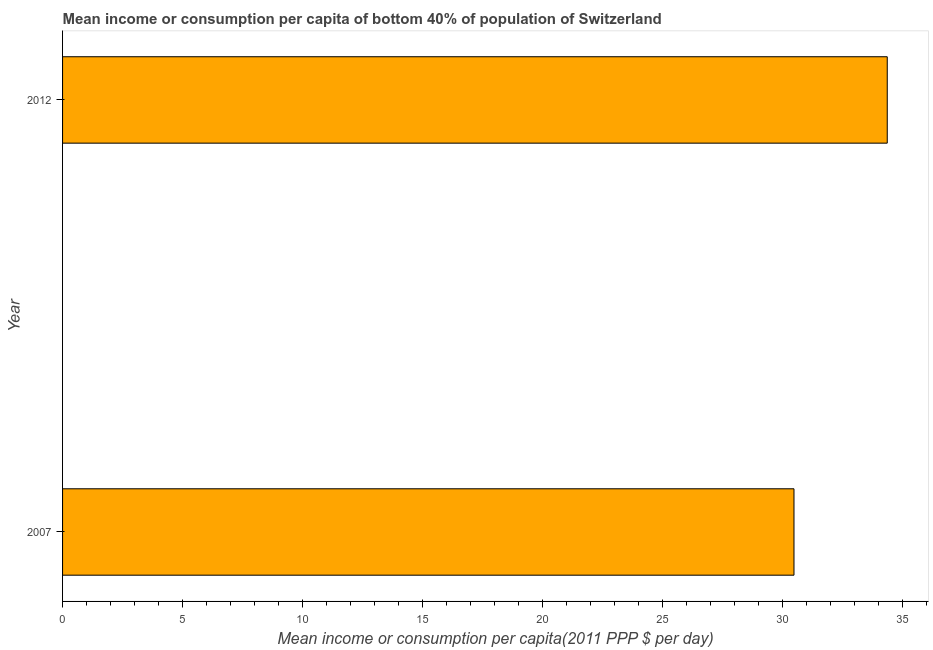Does the graph contain grids?
Make the answer very short. No. What is the title of the graph?
Provide a succinct answer. Mean income or consumption per capita of bottom 40% of population of Switzerland. What is the label or title of the X-axis?
Provide a short and direct response. Mean income or consumption per capita(2011 PPP $ per day). What is the label or title of the Y-axis?
Keep it short and to the point. Year. What is the mean income or consumption in 2012?
Give a very brief answer. 34.38. Across all years, what is the maximum mean income or consumption?
Give a very brief answer. 34.38. Across all years, what is the minimum mean income or consumption?
Keep it short and to the point. 30.49. In which year was the mean income or consumption minimum?
Your response must be concise. 2007. What is the sum of the mean income or consumption?
Your answer should be very brief. 64.87. What is the difference between the mean income or consumption in 2007 and 2012?
Give a very brief answer. -3.89. What is the average mean income or consumption per year?
Ensure brevity in your answer.  32.44. What is the median mean income or consumption?
Provide a short and direct response. 32.43. In how many years, is the mean income or consumption greater than 27 $?
Your answer should be compact. 2. Do a majority of the years between 2007 and 2012 (inclusive) have mean income or consumption greater than 24 $?
Keep it short and to the point. Yes. What is the ratio of the mean income or consumption in 2007 to that in 2012?
Ensure brevity in your answer.  0.89. In how many years, is the mean income or consumption greater than the average mean income or consumption taken over all years?
Offer a very short reply. 1. Are all the bars in the graph horizontal?
Keep it short and to the point. Yes. How many years are there in the graph?
Provide a succinct answer. 2. Are the values on the major ticks of X-axis written in scientific E-notation?
Keep it short and to the point. No. What is the Mean income or consumption per capita(2011 PPP $ per day) of 2007?
Offer a very short reply. 30.49. What is the Mean income or consumption per capita(2011 PPP $ per day) in 2012?
Your answer should be very brief. 34.38. What is the difference between the Mean income or consumption per capita(2011 PPP $ per day) in 2007 and 2012?
Offer a terse response. -3.89. What is the ratio of the Mean income or consumption per capita(2011 PPP $ per day) in 2007 to that in 2012?
Your answer should be compact. 0.89. 